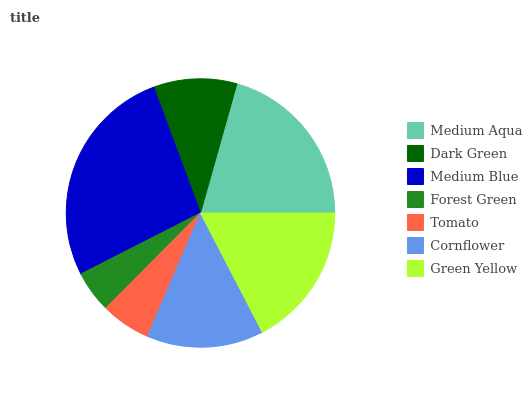Is Forest Green the minimum?
Answer yes or no. Yes. Is Medium Blue the maximum?
Answer yes or no. Yes. Is Dark Green the minimum?
Answer yes or no. No. Is Dark Green the maximum?
Answer yes or no. No. Is Medium Aqua greater than Dark Green?
Answer yes or no. Yes. Is Dark Green less than Medium Aqua?
Answer yes or no. Yes. Is Dark Green greater than Medium Aqua?
Answer yes or no. No. Is Medium Aqua less than Dark Green?
Answer yes or no. No. Is Cornflower the high median?
Answer yes or no. Yes. Is Cornflower the low median?
Answer yes or no. Yes. Is Forest Green the high median?
Answer yes or no. No. Is Medium Blue the low median?
Answer yes or no. No. 